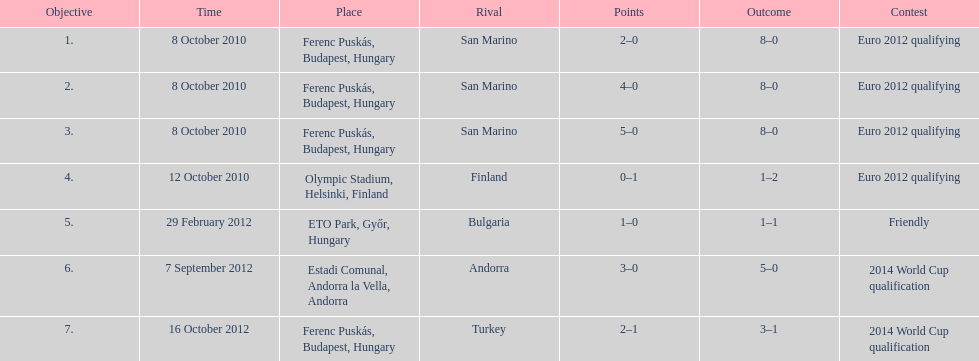In what year was szalai's first international goal? 2010. 